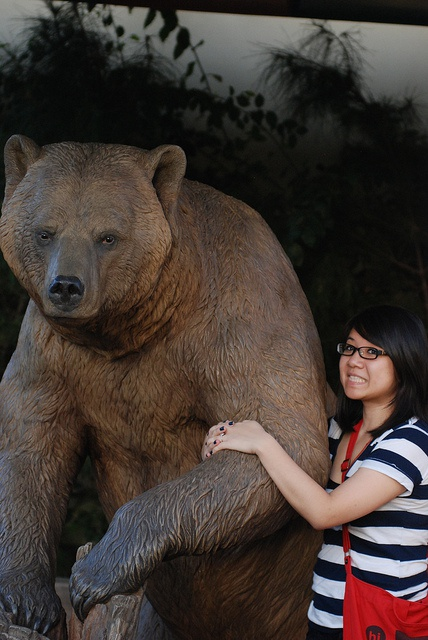Describe the objects in this image and their specific colors. I can see bear in darkgray, black, gray, and maroon tones, people in darkgray, black, tan, brown, and lavender tones, and handbag in darkgray, brown, maroon, and black tones in this image. 